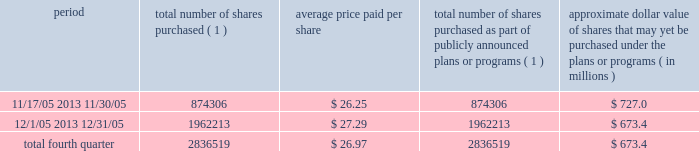Discussion and analysis of financial condition and results of operations 2014liquidity and capital resources 2014 factors affecting sources of liquidity . 201d recent sales of unregistered securities during the year ended december 31 , 2005 , we issued an aggregate of 4670335 shares of our class a common stock upon conversion of $ 57.1 million principal amount of our 3.25% ( 3.25 % ) notes .
Pursuant to the terms of the indenture , the holders of the 3.25% ( 3.25 % ) notes received 81.808 shares of class a common stock for every $ 1000 principal amount of notes converted .
The shares were issued to the noteholders in reliance on the exemption from registration set forth in section 3 ( a ) ( 9 ) of the securities act of 1933 , as amended .
No underwriters were engaged in connection with such issuances .
In connection with the conversion , we paid such holders an aggregate of $ 4.9 million , calculated based on the accrued and unpaid interest on the notes and the discounted value of the future interest payments on the notes .
Subsequent to december 31 , 2005 , we issued shares of class a common stock upon conversions of additional 3.25% ( 3.25 % ) notes , as set forth in item 9b of this annual report under the caption 201cother information . 201d during the year ended december 31 , 2005 , we issued an aggregate of 398412 shares of our class a common stock upon exercises of 55729 warrants assumed in our merger with spectrasite , inc .
In august 2005 , in connection with our merger with spectrasite , inc. , we assumed approximately 1.0 million warrants to purchase shares of spectrasite , inc .
Common stock .
Upon completion of the merger , each warrant to purchase shares of spectrasite , inc .
Common stock automatically converted into a warrant to purchase 7.15 shares of class a common stock at an exercise price of $ 32 per warrant .
Net proceeds from these warrant exercises were approximately $ 1.8 million .
The shares of class a common stock issued to the warrantholders upon exercise of the warrants were issued in reliance on the exemption from registration set forth in section 3 ( a ) ( 9 ) of the securities act of 1933 , as amended .
No underwriters were engaged in connection with such issuances .
Subsequent to december 31 , 2005 , we issued shares of class a common stock upon exercises of additional warrants , as set forth in item 9b of this annual report under the caption 201cother information . 201d issuer purchases of equity securities in november 2005 , we announced that our board of directors had approved a stock repurchase program pursuant to which we intend to repurchase up to $ 750.0 million of our class a common stock through december 2006 .
During the fourth quarter of 2005 , we repurchased 2836519 shares of our class a common stock for an aggregate of $ 76.6 million pursuant to our stock repurchase program , as follows : period total number of shares purchased ( 1 ) average price paid per share total number of shares purchased as part of publicly announced plans or programs ( 1 ) approximate dollar value of shares that may yet be purchased under the plans or programs ( in millions ) .
( 1 ) all issuer repurchases were made pursuant to the stock repurchase program publicly announced in november 2005 .
Pursuant to the program , we intend to repurchase up to $ 750.0 million of our class a common stock during the period november 2005 through december 2006 .
Under the program , our management is authorized to purchase shares from time to time in open market purchases or privately negotiated transactions at prevailing prices as permitted by securities laws and other legal requirements , and subject to market conditions and other factors .
To facilitate repurchases , we entered into a trading plan under rule 10b5-1 of the securities exchange act of 1934 , which allows us to repurchase shares during periods when we otherwise might be prevented from doing so under insider trading laws or because of self- imposed trading blackout periods .
The program may be discontinued at any time .
Since december 31 , 2005 , we have continued to repurchase shares of our class a common stock pursuant to our stock repurchase program .
Between january 1 , 2006 and march 9 , 2006 , we repurchased 3.9 million shares of class a common stock for an aggregate of $ 117.4 million pursuant to the stock repurchase program. .
What is the total amount of cash used for stock repurchase during november 2005 , in millions? 
Computations: ((874306 * 26.25) / 1000000)
Answer: 22.95053. 